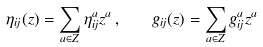Convert formula to latex. <formula><loc_0><loc_0><loc_500><loc_500>\eta _ { i j } ( z ) = \sum _ { a \in { Z } } \eta ^ { a } _ { i j } z ^ { a } \, , \quad g _ { i j } ( z ) = \sum _ { a \in { Z } } g ^ { a } _ { i j } z ^ { a }</formula> 